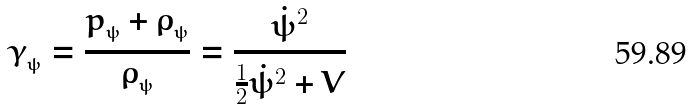Convert formula to latex. <formula><loc_0><loc_0><loc_500><loc_500>\gamma _ { _ { \psi } } = \frac { p _ { _ { \psi } } + \rho _ { _ { \psi } } } { \rho _ { _ { \psi } } } = \frac { \dot { \psi } ^ { 2 } } { \frac { 1 } { 2 } \dot { \psi } ^ { 2 } + V }</formula> 